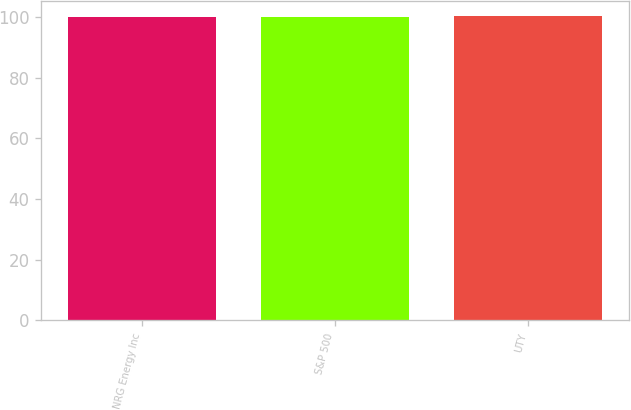Convert chart to OTSL. <chart><loc_0><loc_0><loc_500><loc_500><bar_chart><fcel>NRG Energy Inc<fcel>S&P 500<fcel>UTY<nl><fcel>100<fcel>100.1<fcel>100.2<nl></chart> 